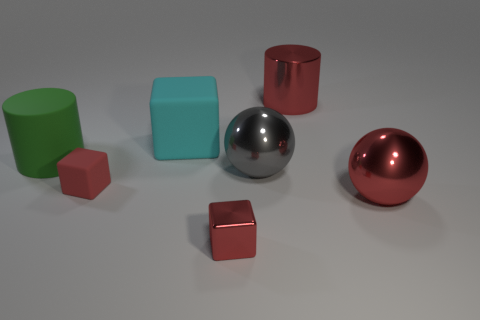Subtract all blue blocks. Subtract all green spheres. How many blocks are left? 3 Subtract all purple balls. How many purple blocks are left? 0 Add 7 cyans. How many small reds exist? 0 Subtract all rubber things. Subtract all red cubes. How many objects are left? 2 Add 2 big red cylinders. How many big red cylinders are left? 3 Add 7 small shiny blocks. How many small shiny blocks exist? 8 Add 2 red shiny cylinders. How many objects exist? 9 Subtract all gray balls. How many balls are left? 1 Subtract all large matte blocks. How many blocks are left? 2 Subtract 1 cyan blocks. How many objects are left? 6 